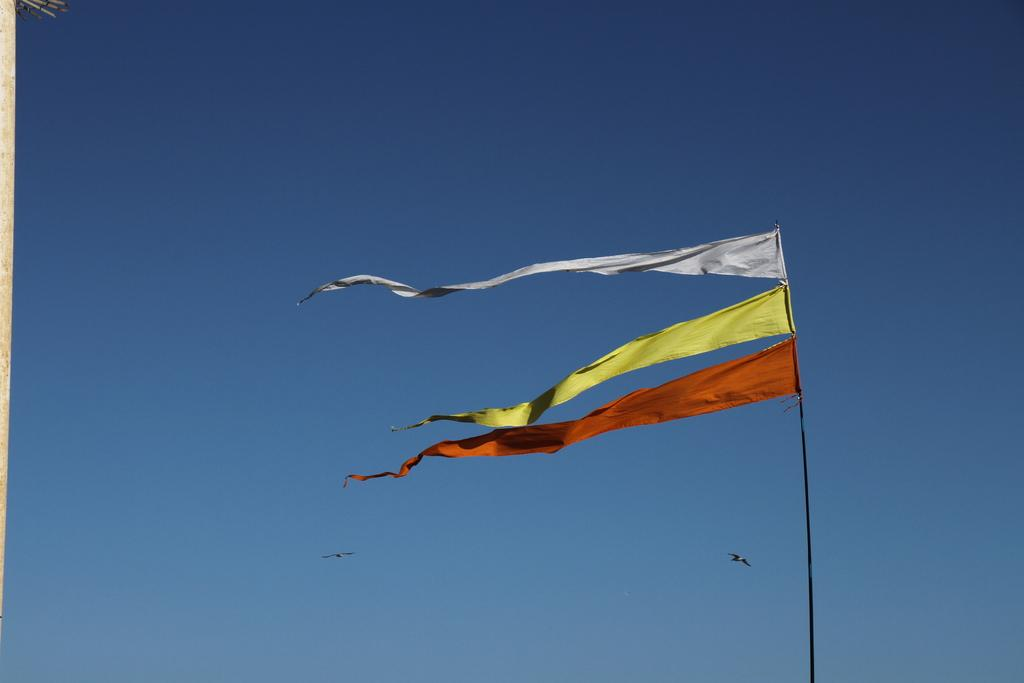What is present in the image that represents a symbol or country? There is a flag in the image. What can be seen in the sky in the image? There are two birds flying in the sky in the image. What is visible at the top of the image? The sky is visible at the top of the image. What might be supporting the flag in the image? There might be a pole or wall on the left side of the image. Can you tell me what type of ear is visible on the flag in the image? There is no ear present on the flag in the image. The flag represents a symbol or country, but it does not have any ears. 